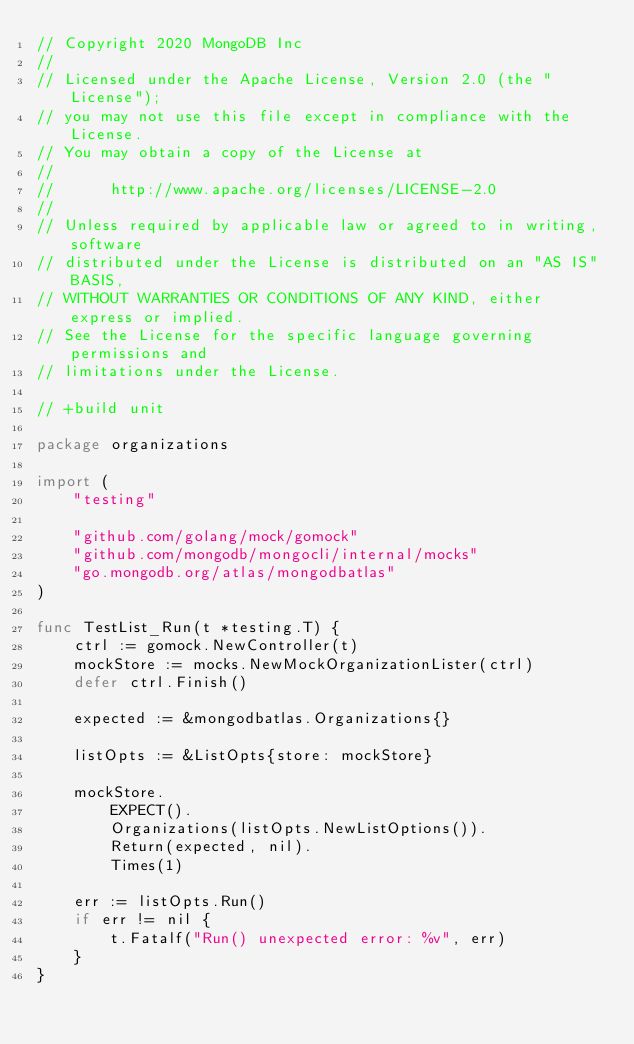Convert code to text. <code><loc_0><loc_0><loc_500><loc_500><_Go_>// Copyright 2020 MongoDB Inc
//
// Licensed under the Apache License, Version 2.0 (the "License");
// you may not use this file except in compliance with the License.
// You may obtain a copy of the License at
//
//      http://www.apache.org/licenses/LICENSE-2.0
//
// Unless required by applicable law or agreed to in writing, software
// distributed under the License is distributed on an "AS IS" BASIS,
// WITHOUT WARRANTIES OR CONDITIONS OF ANY KIND, either express or implied.
// See the License for the specific language governing permissions and
// limitations under the License.

// +build unit

package organizations

import (
	"testing"

	"github.com/golang/mock/gomock"
	"github.com/mongodb/mongocli/internal/mocks"
	"go.mongodb.org/atlas/mongodbatlas"
)

func TestList_Run(t *testing.T) {
	ctrl := gomock.NewController(t)
	mockStore := mocks.NewMockOrganizationLister(ctrl)
	defer ctrl.Finish()

	expected := &mongodbatlas.Organizations{}

	listOpts := &ListOpts{store: mockStore}

	mockStore.
		EXPECT().
		Organizations(listOpts.NewListOptions()).
		Return(expected, nil).
		Times(1)

	err := listOpts.Run()
	if err != nil {
		t.Fatalf("Run() unexpected error: %v", err)
	}
}
</code> 